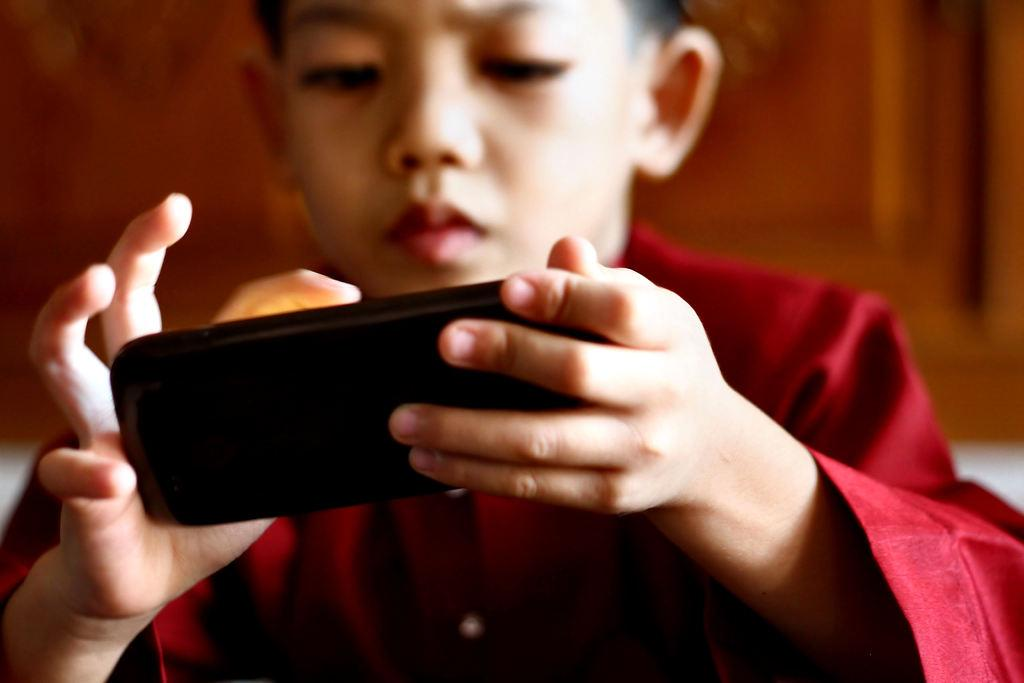Who is the main subject in the picture? There is a boy in the picture. What is the boy holding in the picture? The boy is holding a mobile phone. What is the boy wearing in the picture? The boy is wearing a red color dress. What type of trousers is the boy wearing in the picture? The provided facts do not mention any trousers; the boy is wearing a red color dress. Can you see a coil in the picture? There is no mention of a coil in the provided facts, so it cannot be determined if one is present in the image. 